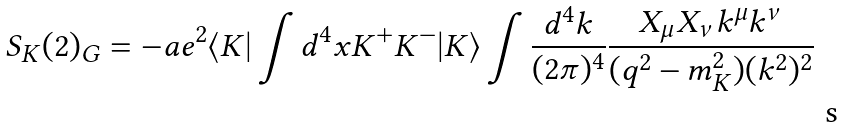Convert formula to latex. <formula><loc_0><loc_0><loc_500><loc_500>S _ { K } ( 2 ) _ { G } = - a e ^ { 2 } \langle K | \int d ^ { 4 } x K ^ { + } K ^ { - } | K \rangle \int \frac { d ^ { 4 } k } { ( 2 \pi ) ^ { 4 } } \frac { X _ { \mu } X _ { \nu } k ^ { \mu } k ^ { \nu } } { ( q ^ { 2 } - m _ { K } ^ { 2 } ) ( k ^ { 2 } ) ^ { 2 } }</formula> 